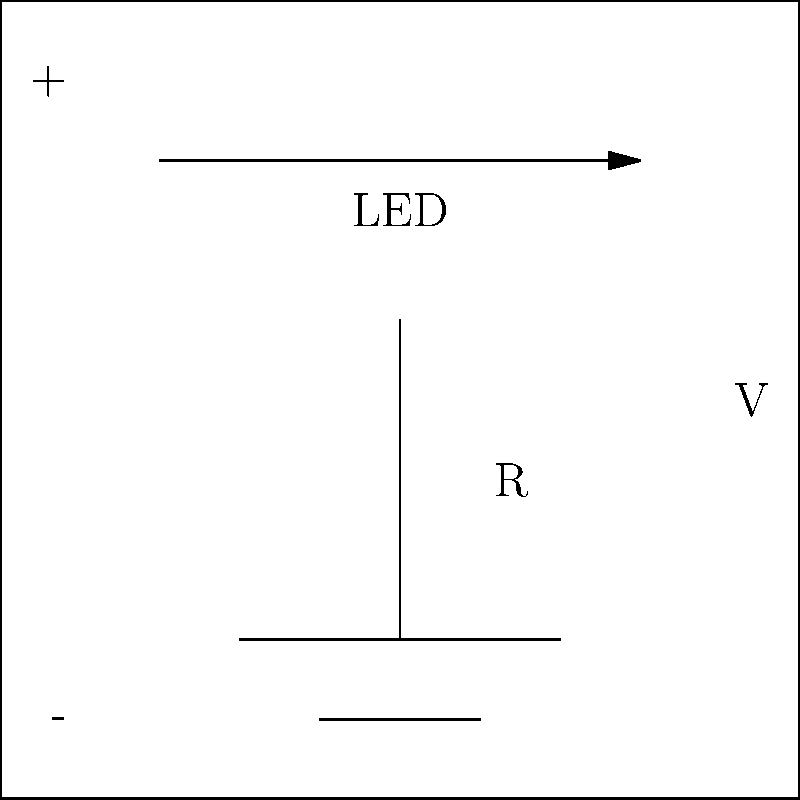In the given circuit diagram for a basic LED light setup, what is the purpose of the component labeled 'R' in relation to the LED's operation? To understand the purpose of the component labeled 'R' in this circuit:

1. Identify the components:
   - The triangle with an arrow represents an LED (Light Emitting Diode)
   - 'R' represents a resistor
   - 'V' represents a voltage source

2. Understand LED characteristics:
   - LEDs require a specific forward voltage to operate
   - They are sensitive to excess current

3. Role of the resistor:
   - It limits the current flowing through the LED
   - Protects the LED from damage due to excessive current
   - Helps maintain the appropriate voltage across the LED

4. Ohm's Law application:
   - The resistor creates a voltage drop: $V_R = I * R$
   - This ensures the LED receives its required forward voltage

5. Industry relevance:
   - Proper LED protection extends product lifespan
   - Ensures consistent brightness and performance
   - Impacts energy efficiency and product reliability

Therefore, the resistor (R) serves as a current-limiting device to protect the LED and ensure its proper operation.
Answer: Current-limiting device to protect the LED 